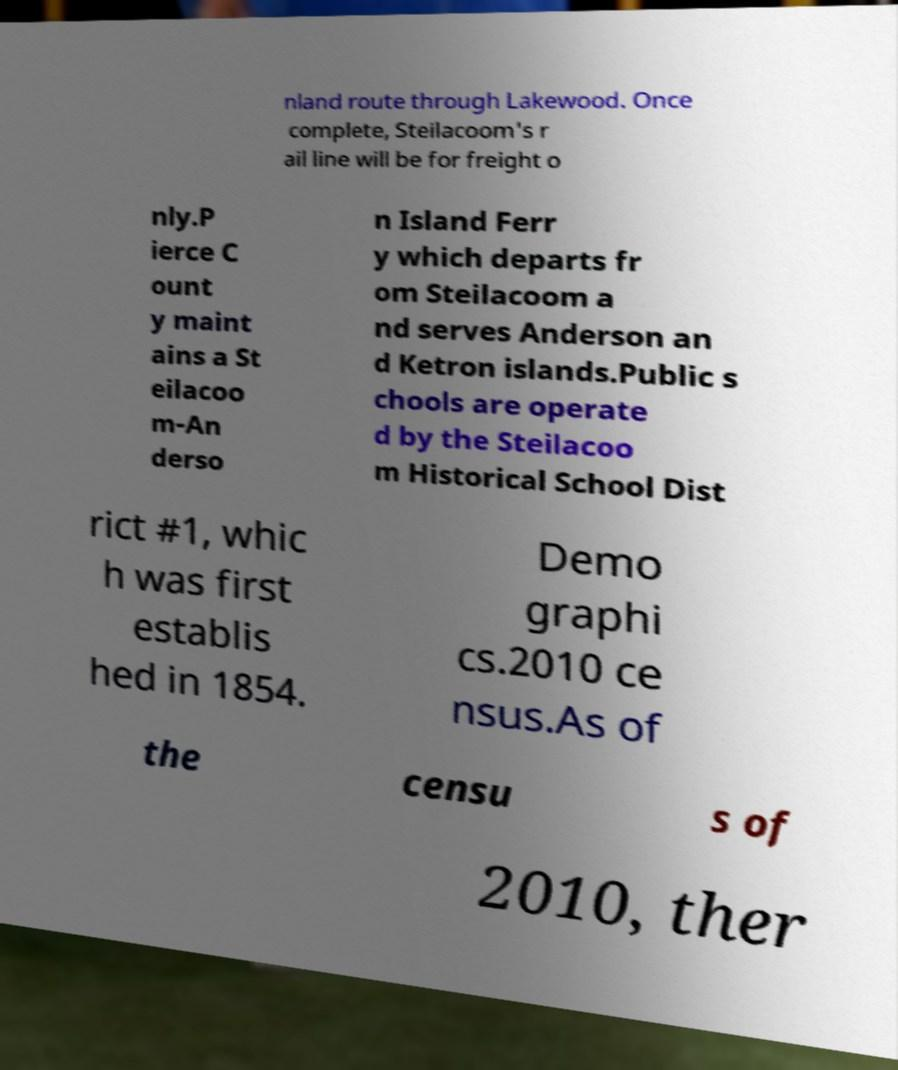Could you assist in decoding the text presented in this image and type it out clearly? nland route through Lakewood. Once complete, Steilacoom's r ail line will be for freight o nly.P ierce C ount y maint ains a St eilacoo m-An derso n Island Ferr y which departs fr om Steilacoom a nd serves Anderson an d Ketron islands.Public s chools are operate d by the Steilacoo m Historical School Dist rict #1, whic h was first establis hed in 1854. Demo graphi cs.2010 ce nsus.As of the censu s of 2010, ther 